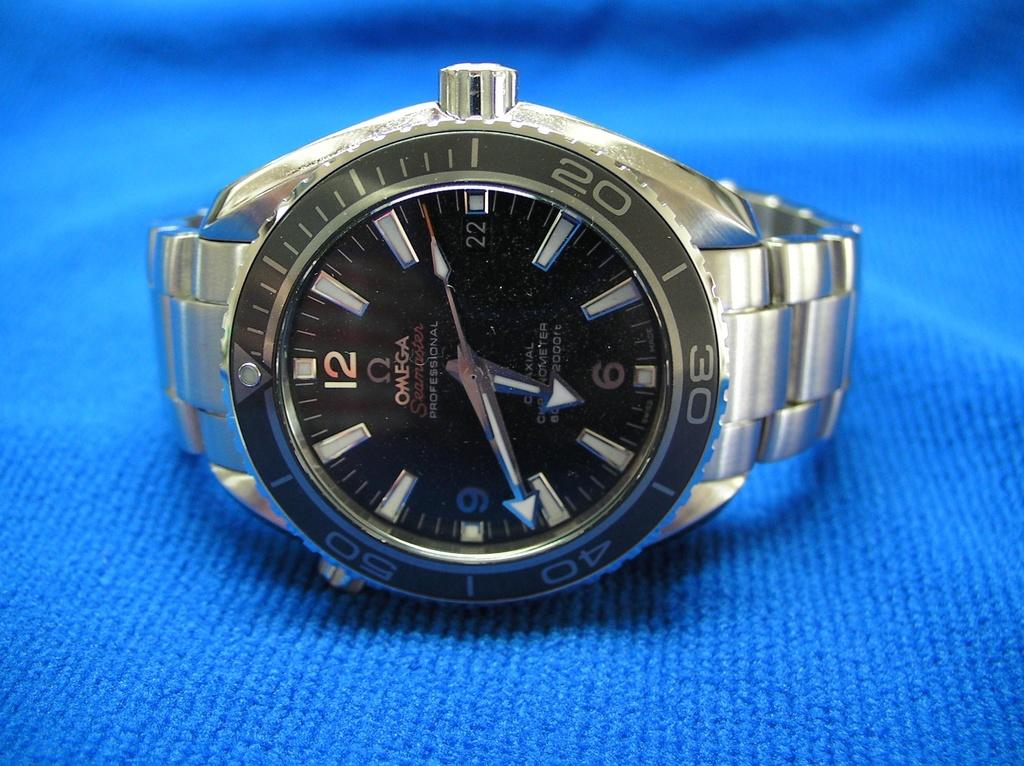<image>
Create a compact narrative representing the image presented. A watch resting on it's side on a blue cloth and the number 40 is shown on the watch face. 